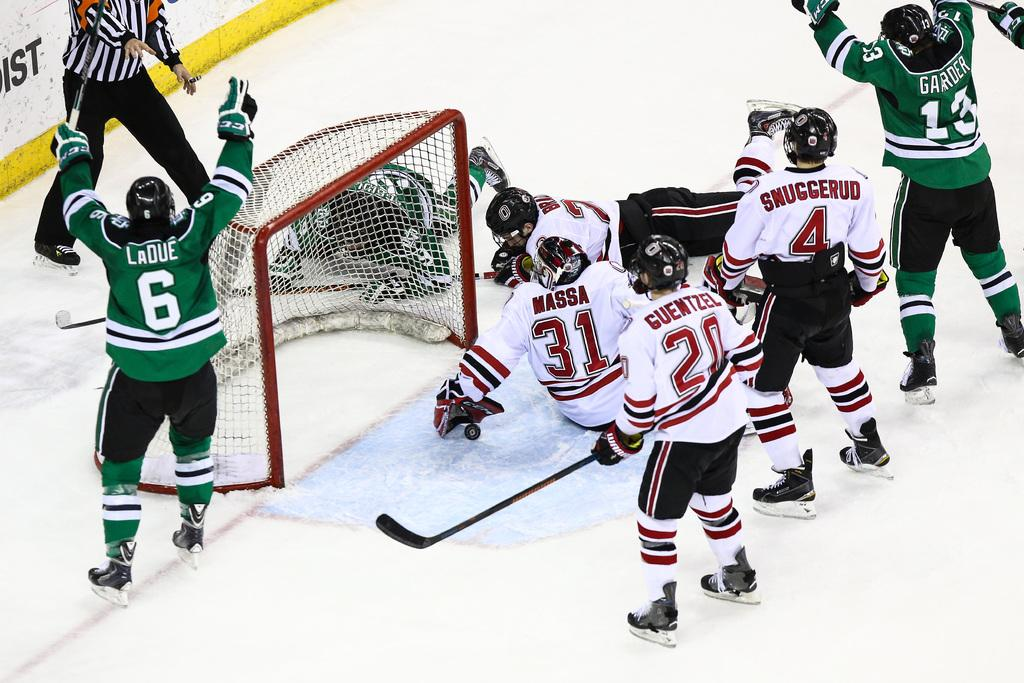What are the two people holding in the image? The two people are holding ice hockey sticks in the image. What is the purpose of the structure in the image? There is a goalpost in the image, which is used in ice hockey for scoring points. What type of footwear are the people wearing in the image? The people are wearing ice skates in the image. What else can be seen in the image besides the people and the goalpost? There are other objects visible in the image. What is written on the wall in the image? There is text on a wall in the image. What grade did the cannon receive in the image? There is no cannon present in the image, and therefore no grade can be assigned. What discovery was made by the people in the image? There is no indication of a discovery being made in the image; it depicts people playing ice hockey. 